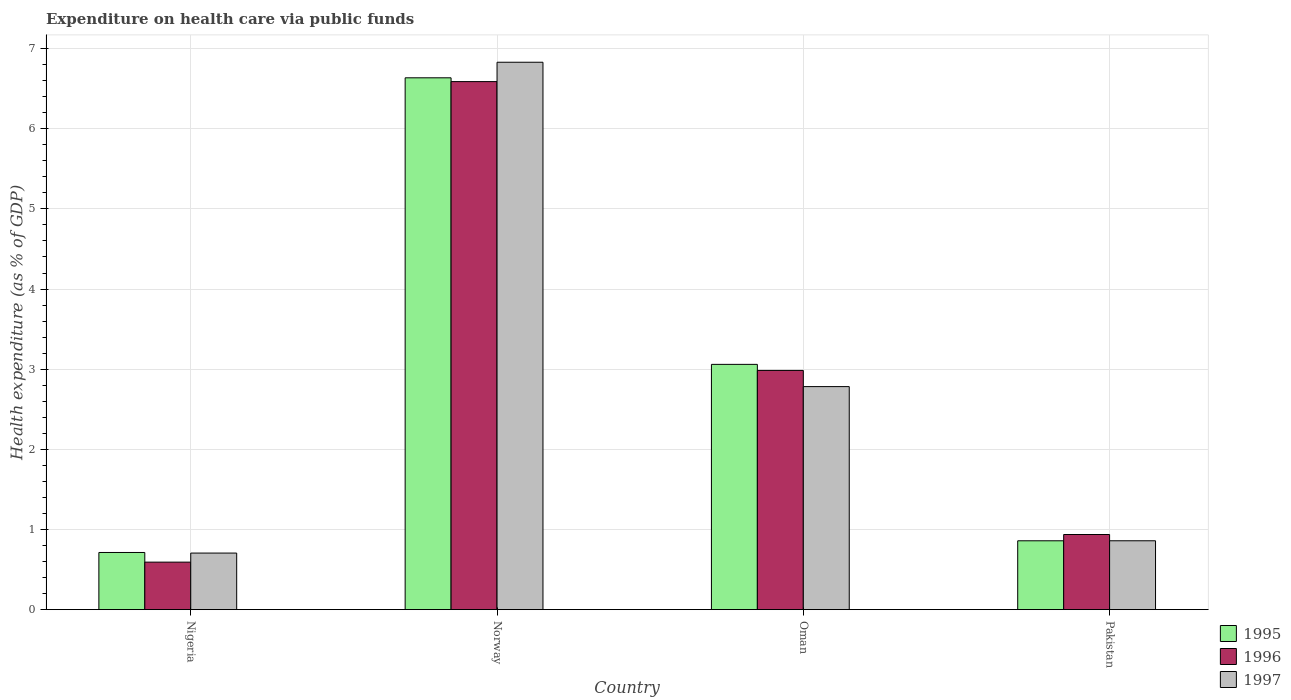How many different coloured bars are there?
Make the answer very short. 3. Are the number of bars per tick equal to the number of legend labels?
Make the answer very short. Yes. Are the number of bars on each tick of the X-axis equal?
Give a very brief answer. Yes. How many bars are there on the 1st tick from the left?
Provide a succinct answer. 3. How many bars are there on the 1st tick from the right?
Provide a succinct answer. 3. What is the label of the 3rd group of bars from the left?
Make the answer very short. Oman. What is the expenditure made on health care in 1997 in Pakistan?
Provide a short and direct response. 0.86. Across all countries, what is the maximum expenditure made on health care in 1997?
Offer a terse response. 6.83. Across all countries, what is the minimum expenditure made on health care in 1996?
Make the answer very short. 0.59. In which country was the expenditure made on health care in 1995 minimum?
Keep it short and to the point. Nigeria. What is the total expenditure made on health care in 1995 in the graph?
Your response must be concise. 11.27. What is the difference between the expenditure made on health care in 1997 in Norway and that in Oman?
Offer a terse response. 4.05. What is the difference between the expenditure made on health care in 1997 in Norway and the expenditure made on health care in 1996 in Oman?
Your answer should be compact. 3.85. What is the average expenditure made on health care in 1995 per country?
Offer a terse response. 2.82. What is the difference between the expenditure made on health care of/in 1995 and expenditure made on health care of/in 1996 in Pakistan?
Your response must be concise. -0.08. In how many countries, is the expenditure made on health care in 1995 greater than 6.2 %?
Make the answer very short. 1. What is the ratio of the expenditure made on health care in 1996 in Norway to that in Oman?
Keep it short and to the point. 2.21. What is the difference between the highest and the second highest expenditure made on health care in 1995?
Ensure brevity in your answer.  -2.2. What is the difference between the highest and the lowest expenditure made on health care in 1997?
Provide a short and direct response. 6.12. In how many countries, is the expenditure made on health care in 1996 greater than the average expenditure made on health care in 1996 taken over all countries?
Make the answer very short. 2. What does the 2nd bar from the left in Oman represents?
Your answer should be compact. 1996. What does the 3rd bar from the right in Norway represents?
Provide a succinct answer. 1995. What is the difference between two consecutive major ticks on the Y-axis?
Your answer should be very brief. 1. Are the values on the major ticks of Y-axis written in scientific E-notation?
Your answer should be compact. No. Does the graph contain any zero values?
Your response must be concise. No. Where does the legend appear in the graph?
Your answer should be very brief. Bottom right. What is the title of the graph?
Provide a short and direct response. Expenditure on health care via public funds. Does "2001" appear as one of the legend labels in the graph?
Your answer should be very brief. No. What is the label or title of the Y-axis?
Provide a short and direct response. Health expenditure (as % of GDP). What is the Health expenditure (as % of GDP) in 1995 in Nigeria?
Your answer should be compact. 0.71. What is the Health expenditure (as % of GDP) in 1996 in Nigeria?
Your answer should be very brief. 0.59. What is the Health expenditure (as % of GDP) in 1997 in Nigeria?
Your response must be concise. 0.71. What is the Health expenditure (as % of GDP) of 1995 in Norway?
Offer a terse response. 6.64. What is the Health expenditure (as % of GDP) in 1996 in Norway?
Your answer should be very brief. 6.59. What is the Health expenditure (as % of GDP) of 1997 in Norway?
Offer a very short reply. 6.83. What is the Health expenditure (as % of GDP) in 1995 in Oman?
Your answer should be very brief. 3.06. What is the Health expenditure (as % of GDP) in 1996 in Oman?
Provide a short and direct response. 2.98. What is the Health expenditure (as % of GDP) in 1997 in Oman?
Make the answer very short. 2.78. What is the Health expenditure (as % of GDP) of 1995 in Pakistan?
Keep it short and to the point. 0.86. What is the Health expenditure (as % of GDP) in 1996 in Pakistan?
Ensure brevity in your answer.  0.94. What is the Health expenditure (as % of GDP) in 1997 in Pakistan?
Provide a succinct answer. 0.86. Across all countries, what is the maximum Health expenditure (as % of GDP) in 1995?
Your response must be concise. 6.64. Across all countries, what is the maximum Health expenditure (as % of GDP) in 1996?
Offer a very short reply. 6.59. Across all countries, what is the maximum Health expenditure (as % of GDP) in 1997?
Provide a short and direct response. 6.83. Across all countries, what is the minimum Health expenditure (as % of GDP) of 1995?
Ensure brevity in your answer.  0.71. Across all countries, what is the minimum Health expenditure (as % of GDP) in 1996?
Ensure brevity in your answer.  0.59. Across all countries, what is the minimum Health expenditure (as % of GDP) in 1997?
Offer a very short reply. 0.71. What is the total Health expenditure (as % of GDP) of 1995 in the graph?
Make the answer very short. 11.27. What is the total Health expenditure (as % of GDP) of 1996 in the graph?
Your answer should be compact. 11.1. What is the total Health expenditure (as % of GDP) in 1997 in the graph?
Your response must be concise. 11.18. What is the difference between the Health expenditure (as % of GDP) in 1995 in Nigeria and that in Norway?
Make the answer very short. -5.92. What is the difference between the Health expenditure (as % of GDP) in 1996 in Nigeria and that in Norway?
Provide a short and direct response. -6. What is the difference between the Health expenditure (as % of GDP) of 1997 in Nigeria and that in Norway?
Your answer should be very brief. -6.12. What is the difference between the Health expenditure (as % of GDP) in 1995 in Nigeria and that in Oman?
Provide a short and direct response. -2.35. What is the difference between the Health expenditure (as % of GDP) in 1996 in Nigeria and that in Oman?
Make the answer very short. -2.39. What is the difference between the Health expenditure (as % of GDP) of 1997 in Nigeria and that in Oman?
Give a very brief answer. -2.08. What is the difference between the Health expenditure (as % of GDP) of 1995 in Nigeria and that in Pakistan?
Make the answer very short. -0.15. What is the difference between the Health expenditure (as % of GDP) of 1996 in Nigeria and that in Pakistan?
Your answer should be compact. -0.34. What is the difference between the Health expenditure (as % of GDP) of 1997 in Nigeria and that in Pakistan?
Offer a very short reply. -0.15. What is the difference between the Health expenditure (as % of GDP) of 1995 in Norway and that in Oman?
Provide a short and direct response. 3.58. What is the difference between the Health expenditure (as % of GDP) of 1996 in Norway and that in Oman?
Provide a short and direct response. 3.6. What is the difference between the Health expenditure (as % of GDP) of 1997 in Norway and that in Oman?
Offer a terse response. 4.05. What is the difference between the Health expenditure (as % of GDP) of 1995 in Norway and that in Pakistan?
Offer a very short reply. 5.78. What is the difference between the Health expenditure (as % of GDP) of 1996 in Norway and that in Pakistan?
Offer a terse response. 5.65. What is the difference between the Health expenditure (as % of GDP) in 1997 in Norway and that in Pakistan?
Offer a very short reply. 5.97. What is the difference between the Health expenditure (as % of GDP) in 1995 in Oman and that in Pakistan?
Ensure brevity in your answer.  2.2. What is the difference between the Health expenditure (as % of GDP) in 1996 in Oman and that in Pakistan?
Your response must be concise. 2.05. What is the difference between the Health expenditure (as % of GDP) of 1997 in Oman and that in Pakistan?
Your answer should be compact. 1.92. What is the difference between the Health expenditure (as % of GDP) in 1995 in Nigeria and the Health expenditure (as % of GDP) in 1996 in Norway?
Ensure brevity in your answer.  -5.88. What is the difference between the Health expenditure (as % of GDP) of 1995 in Nigeria and the Health expenditure (as % of GDP) of 1997 in Norway?
Provide a short and direct response. -6.12. What is the difference between the Health expenditure (as % of GDP) of 1996 in Nigeria and the Health expenditure (as % of GDP) of 1997 in Norway?
Offer a terse response. -6.24. What is the difference between the Health expenditure (as % of GDP) of 1995 in Nigeria and the Health expenditure (as % of GDP) of 1996 in Oman?
Offer a very short reply. -2.27. What is the difference between the Health expenditure (as % of GDP) in 1995 in Nigeria and the Health expenditure (as % of GDP) in 1997 in Oman?
Provide a short and direct response. -2.07. What is the difference between the Health expenditure (as % of GDP) in 1996 in Nigeria and the Health expenditure (as % of GDP) in 1997 in Oman?
Keep it short and to the point. -2.19. What is the difference between the Health expenditure (as % of GDP) in 1995 in Nigeria and the Health expenditure (as % of GDP) in 1996 in Pakistan?
Provide a short and direct response. -0.22. What is the difference between the Health expenditure (as % of GDP) of 1995 in Nigeria and the Health expenditure (as % of GDP) of 1997 in Pakistan?
Give a very brief answer. -0.15. What is the difference between the Health expenditure (as % of GDP) in 1996 in Nigeria and the Health expenditure (as % of GDP) in 1997 in Pakistan?
Keep it short and to the point. -0.27. What is the difference between the Health expenditure (as % of GDP) of 1995 in Norway and the Health expenditure (as % of GDP) of 1996 in Oman?
Keep it short and to the point. 3.65. What is the difference between the Health expenditure (as % of GDP) in 1995 in Norway and the Health expenditure (as % of GDP) in 1997 in Oman?
Your answer should be compact. 3.85. What is the difference between the Health expenditure (as % of GDP) of 1996 in Norway and the Health expenditure (as % of GDP) of 1997 in Oman?
Your answer should be compact. 3.81. What is the difference between the Health expenditure (as % of GDP) of 1995 in Norway and the Health expenditure (as % of GDP) of 1996 in Pakistan?
Make the answer very short. 5.7. What is the difference between the Health expenditure (as % of GDP) of 1995 in Norway and the Health expenditure (as % of GDP) of 1997 in Pakistan?
Your response must be concise. 5.78. What is the difference between the Health expenditure (as % of GDP) in 1996 in Norway and the Health expenditure (as % of GDP) in 1997 in Pakistan?
Make the answer very short. 5.73. What is the difference between the Health expenditure (as % of GDP) of 1995 in Oman and the Health expenditure (as % of GDP) of 1996 in Pakistan?
Your answer should be compact. 2.12. What is the difference between the Health expenditure (as % of GDP) in 1995 in Oman and the Health expenditure (as % of GDP) in 1997 in Pakistan?
Offer a terse response. 2.2. What is the difference between the Health expenditure (as % of GDP) in 1996 in Oman and the Health expenditure (as % of GDP) in 1997 in Pakistan?
Ensure brevity in your answer.  2.13. What is the average Health expenditure (as % of GDP) of 1995 per country?
Your answer should be compact. 2.82. What is the average Health expenditure (as % of GDP) of 1996 per country?
Provide a succinct answer. 2.78. What is the average Health expenditure (as % of GDP) in 1997 per country?
Provide a succinct answer. 2.79. What is the difference between the Health expenditure (as % of GDP) in 1995 and Health expenditure (as % of GDP) in 1996 in Nigeria?
Your response must be concise. 0.12. What is the difference between the Health expenditure (as % of GDP) of 1995 and Health expenditure (as % of GDP) of 1997 in Nigeria?
Offer a very short reply. 0.01. What is the difference between the Health expenditure (as % of GDP) in 1996 and Health expenditure (as % of GDP) in 1997 in Nigeria?
Your answer should be compact. -0.11. What is the difference between the Health expenditure (as % of GDP) in 1995 and Health expenditure (as % of GDP) in 1996 in Norway?
Give a very brief answer. 0.05. What is the difference between the Health expenditure (as % of GDP) of 1995 and Health expenditure (as % of GDP) of 1997 in Norway?
Your answer should be very brief. -0.19. What is the difference between the Health expenditure (as % of GDP) in 1996 and Health expenditure (as % of GDP) in 1997 in Norway?
Your answer should be very brief. -0.24. What is the difference between the Health expenditure (as % of GDP) in 1995 and Health expenditure (as % of GDP) in 1996 in Oman?
Your answer should be compact. 0.08. What is the difference between the Health expenditure (as % of GDP) of 1995 and Health expenditure (as % of GDP) of 1997 in Oman?
Provide a succinct answer. 0.28. What is the difference between the Health expenditure (as % of GDP) in 1996 and Health expenditure (as % of GDP) in 1997 in Oman?
Offer a terse response. 0.2. What is the difference between the Health expenditure (as % of GDP) of 1995 and Health expenditure (as % of GDP) of 1996 in Pakistan?
Provide a short and direct response. -0.08. What is the difference between the Health expenditure (as % of GDP) in 1995 and Health expenditure (as % of GDP) in 1997 in Pakistan?
Provide a short and direct response. -0. What is the difference between the Health expenditure (as % of GDP) of 1996 and Health expenditure (as % of GDP) of 1997 in Pakistan?
Make the answer very short. 0.08. What is the ratio of the Health expenditure (as % of GDP) in 1995 in Nigeria to that in Norway?
Your answer should be compact. 0.11. What is the ratio of the Health expenditure (as % of GDP) of 1996 in Nigeria to that in Norway?
Your answer should be compact. 0.09. What is the ratio of the Health expenditure (as % of GDP) of 1997 in Nigeria to that in Norway?
Offer a terse response. 0.1. What is the ratio of the Health expenditure (as % of GDP) in 1995 in Nigeria to that in Oman?
Provide a short and direct response. 0.23. What is the ratio of the Health expenditure (as % of GDP) in 1996 in Nigeria to that in Oman?
Your answer should be compact. 0.2. What is the ratio of the Health expenditure (as % of GDP) in 1997 in Nigeria to that in Oman?
Ensure brevity in your answer.  0.25. What is the ratio of the Health expenditure (as % of GDP) of 1995 in Nigeria to that in Pakistan?
Keep it short and to the point. 0.83. What is the ratio of the Health expenditure (as % of GDP) of 1996 in Nigeria to that in Pakistan?
Provide a short and direct response. 0.63. What is the ratio of the Health expenditure (as % of GDP) in 1997 in Nigeria to that in Pakistan?
Offer a very short reply. 0.82. What is the ratio of the Health expenditure (as % of GDP) of 1995 in Norway to that in Oman?
Keep it short and to the point. 2.17. What is the ratio of the Health expenditure (as % of GDP) of 1996 in Norway to that in Oman?
Make the answer very short. 2.21. What is the ratio of the Health expenditure (as % of GDP) of 1997 in Norway to that in Oman?
Make the answer very short. 2.45. What is the ratio of the Health expenditure (as % of GDP) in 1995 in Norway to that in Pakistan?
Give a very brief answer. 7.73. What is the ratio of the Health expenditure (as % of GDP) in 1996 in Norway to that in Pakistan?
Your answer should be compact. 7.03. What is the ratio of the Health expenditure (as % of GDP) of 1997 in Norway to that in Pakistan?
Offer a very short reply. 7.95. What is the ratio of the Health expenditure (as % of GDP) in 1995 in Oman to that in Pakistan?
Provide a succinct answer. 3.56. What is the ratio of the Health expenditure (as % of GDP) in 1996 in Oman to that in Pakistan?
Your answer should be compact. 3.18. What is the ratio of the Health expenditure (as % of GDP) in 1997 in Oman to that in Pakistan?
Your answer should be very brief. 3.24. What is the difference between the highest and the second highest Health expenditure (as % of GDP) of 1995?
Your answer should be compact. 3.58. What is the difference between the highest and the second highest Health expenditure (as % of GDP) in 1996?
Offer a very short reply. 3.6. What is the difference between the highest and the second highest Health expenditure (as % of GDP) of 1997?
Provide a short and direct response. 4.05. What is the difference between the highest and the lowest Health expenditure (as % of GDP) in 1995?
Give a very brief answer. 5.92. What is the difference between the highest and the lowest Health expenditure (as % of GDP) of 1996?
Your answer should be very brief. 6. What is the difference between the highest and the lowest Health expenditure (as % of GDP) in 1997?
Offer a terse response. 6.12. 